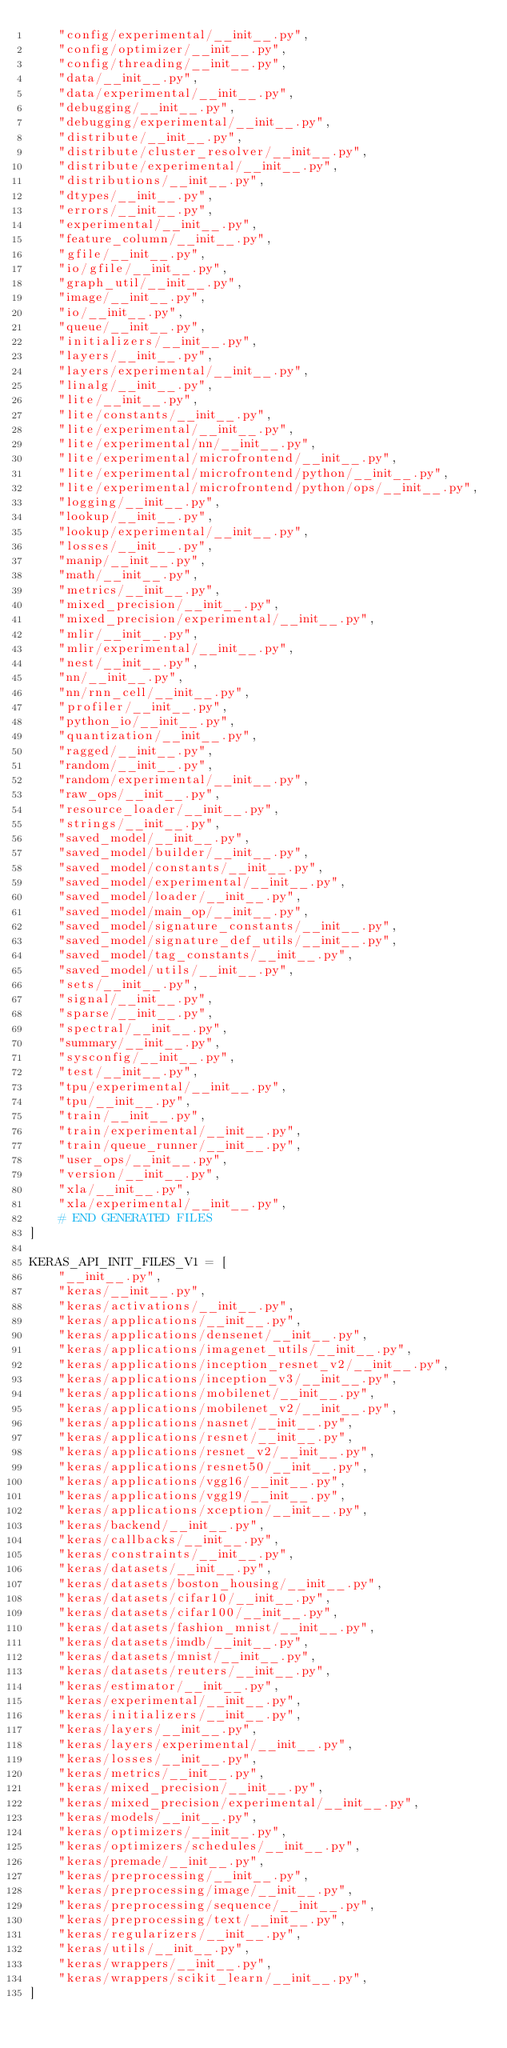<code> <loc_0><loc_0><loc_500><loc_500><_Python_>    "config/experimental/__init__.py",
    "config/optimizer/__init__.py",
    "config/threading/__init__.py",
    "data/__init__.py",
    "data/experimental/__init__.py",
    "debugging/__init__.py",
    "debugging/experimental/__init__.py",
    "distribute/__init__.py",
    "distribute/cluster_resolver/__init__.py",
    "distribute/experimental/__init__.py",
    "distributions/__init__.py",
    "dtypes/__init__.py",
    "errors/__init__.py",
    "experimental/__init__.py",
    "feature_column/__init__.py",
    "gfile/__init__.py",
    "io/gfile/__init__.py",
    "graph_util/__init__.py",
    "image/__init__.py",
    "io/__init__.py",
    "queue/__init__.py",
    "initializers/__init__.py",
    "layers/__init__.py",
    "layers/experimental/__init__.py",
    "linalg/__init__.py",
    "lite/__init__.py",
    "lite/constants/__init__.py",
    "lite/experimental/__init__.py",
    "lite/experimental/nn/__init__.py",
    "lite/experimental/microfrontend/__init__.py",
    "lite/experimental/microfrontend/python/__init__.py",
    "lite/experimental/microfrontend/python/ops/__init__.py",
    "logging/__init__.py",
    "lookup/__init__.py",
    "lookup/experimental/__init__.py",
    "losses/__init__.py",
    "manip/__init__.py",
    "math/__init__.py",
    "metrics/__init__.py",
    "mixed_precision/__init__.py",
    "mixed_precision/experimental/__init__.py",
    "mlir/__init__.py",
    "mlir/experimental/__init__.py",
    "nest/__init__.py",
    "nn/__init__.py",
    "nn/rnn_cell/__init__.py",
    "profiler/__init__.py",
    "python_io/__init__.py",
    "quantization/__init__.py",
    "ragged/__init__.py",
    "random/__init__.py",
    "random/experimental/__init__.py",
    "raw_ops/__init__.py",
    "resource_loader/__init__.py",
    "strings/__init__.py",
    "saved_model/__init__.py",
    "saved_model/builder/__init__.py",
    "saved_model/constants/__init__.py",
    "saved_model/experimental/__init__.py",
    "saved_model/loader/__init__.py",
    "saved_model/main_op/__init__.py",
    "saved_model/signature_constants/__init__.py",
    "saved_model/signature_def_utils/__init__.py",
    "saved_model/tag_constants/__init__.py",
    "saved_model/utils/__init__.py",
    "sets/__init__.py",
    "signal/__init__.py",
    "sparse/__init__.py",
    "spectral/__init__.py",
    "summary/__init__.py",
    "sysconfig/__init__.py",
    "test/__init__.py",
    "tpu/experimental/__init__.py",
    "tpu/__init__.py",
    "train/__init__.py",
    "train/experimental/__init__.py",
    "train/queue_runner/__init__.py",
    "user_ops/__init__.py",
    "version/__init__.py",
    "xla/__init__.py",
    "xla/experimental/__init__.py",
    # END GENERATED FILES
]

KERAS_API_INIT_FILES_V1 = [
    "__init__.py",
    "keras/__init__.py",
    "keras/activations/__init__.py",
    "keras/applications/__init__.py",
    "keras/applications/densenet/__init__.py",
    "keras/applications/imagenet_utils/__init__.py",
    "keras/applications/inception_resnet_v2/__init__.py",
    "keras/applications/inception_v3/__init__.py",
    "keras/applications/mobilenet/__init__.py",
    "keras/applications/mobilenet_v2/__init__.py",
    "keras/applications/nasnet/__init__.py",
    "keras/applications/resnet/__init__.py",
    "keras/applications/resnet_v2/__init__.py",
    "keras/applications/resnet50/__init__.py",
    "keras/applications/vgg16/__init__.py",
    "keras/applications/vgg19/__init__.py",
    "keras/applications/xception/__init__.py",
    "keras/backend/__init__.py",
    "keras/callbacks/__init__.py",
    "keras/constraints/__init__.py",
    "keras/datasets/__init__.py",
    "keras/datasets/boston_housing/__init__.py",
    "keras/datasets/cifar10/__init__.py",
    "keras/datasets/cifar100/__init__.py",
    "keras/datasets/fashion_mnist/__init__.py",
    "keras/datasets/imdb/__init__.py",
    "keras/datasets/mnist/__init__.py",
    "keras/datasets/reuters/__init__.py",
    "keras/estimator/__init__.py",
    "keras/experimental/__init__.py",
    "keras/initializers/__init__.py",
    "keras/layers/__init__.py",
    "keras/layers/experimental/__init__.py",
    "keras/losses/__init__.py",
    "keras/metrics/__init__.py",
    "keras/mixed_precision/__init__.py",
    "keras/mixed_precision/experimental/__init__.py",
    "keras/models/__init__.py",
    "keras/optimizers/__init__.py",
    "keras/optimizers/schedules/__init__.py",
    "keras/premade/__init__.py",
    "keras/preprocessing/__init__.py",
    "keras/preprocessing/image/__init__.py",
    "keras/preprocessing/sequence/__init__.py",
    "keras/preprocessing/text/__init__.py",
    "keras/regularizers/__init__.py",
    "keras/utils/__init__.py",
    "keras/wrappers/__init__.py",
    "keras/wrappers/scikit_learn/__init__.py",
]
</code> 